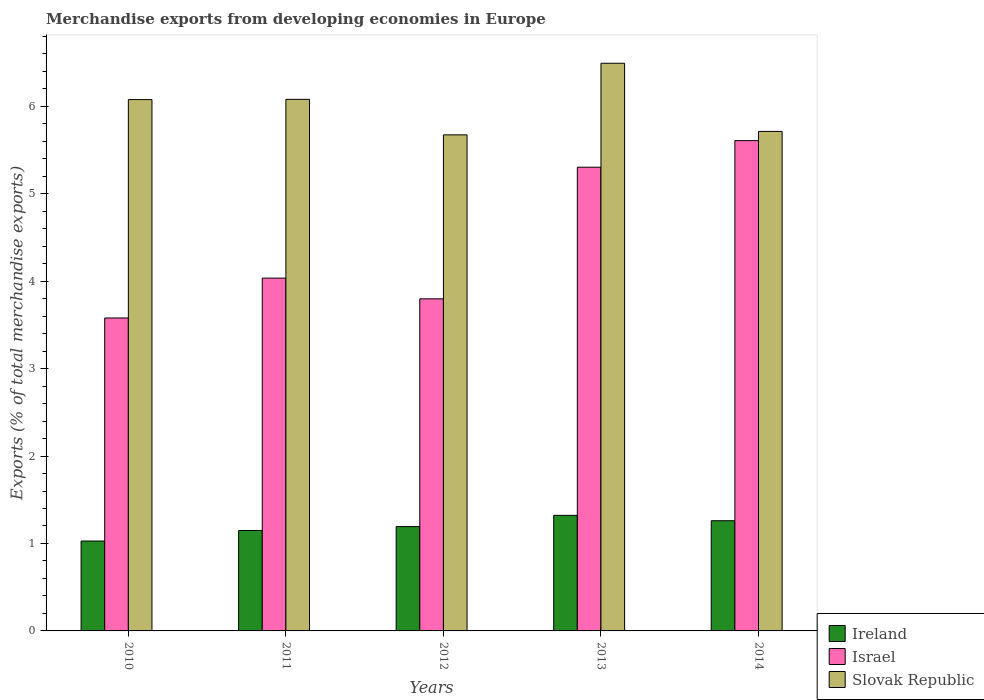How many different coloured bars are there?
Keep it short and to the point. 3. Are the number of bars per tick equal to the number of legend labels?
Provide a short and direct response. Yes. How many bars are there on the 2nd tick from the right?
Ensure brevity in your answer.  3. In how many cases, is the number of bars for a given year not equal to the number of legend labels?
Your answer should be very brief. 0. What is the percentage of total merchandise exports in Ireland in 2014?
Your answer should be compact. 1.26. Across all years, what is the maximum percentage of total merchandise exports in Ireland?
Keep it short and to the point. 1.32. Across all years, what is the minimum percentage of total merchandise exports in Israel?
Make the answer very short. 3.58. In which year was the percentage of total merchandise exports in Ireland minimum?
Your answer should be very brief. 2010. What is the total percentage of total merchandise exports in Slovak Republic in the graph?
Ensure brevity in your answer.  30.03. What is the difference between the percentage of total merchandise exports in Ireland in 2010 and that in 2013?
Offer a terse response. -0.29. What is the difference between the percentage of total merchandise exports in Israel in 2014 and the percentage of total merchandise exports in Slovak Republic in 2013?
Your answer should be very brief. -0.88. What is the average percentage of total merchandise exports in Ireland per year?
Your answer should be compact. 1.19. In the year 2014, what is the difference between the percentage of total merchandise exports in Israel and percentage of total merchandise exports in Ireland?
Provide a succinct answer. 4.35. In how many years, is the percentage of total merchandise exports in Slovak Republic greater than 4.2 %?
Make the answer very short. 5. What is the ratio of the percentage of total merchandise exports in Ireland in 2013 to that in 2014?
Provide a succinct answer. 1.05. Is the percentage of total merchandise exports in Israel in 2011 less than that in 2014?
Your answer should be very brief. Yes. Is the difference between the percentage of total merchandise exports in Israel in 2012 and 2014 greater than the difference between the percentage of total merchandise exports in Ireland in 2012 and 2014?
Your answer should be compact. No. What is the difference between the highest and the second highest percentage of total merchandise exports in Slovak Republic?
Offer a very short reply. 0.41. What is the difference between the highest and the lowest percentage of total merchandise exports in Slovak Republic?
Make the answer very short. 0.82. In how many years, is the percentage of total merchandise exports in Ireland greater than the average percentage of total merchandise exports in Ireland taken over all years?
Your response must be concise. 3. Is the sum of the percentage of total merchandise exports in Israel in 2011 and 2013 greater than the maximum percentage of total merchandise exports in Ireland across all years?
Keep it short and to the point. Yes. What does the 3rd bar from the left in 2014 represents?
Offer a terse response. Slovak Republic. What does the 1st bar from the right in 2013 represents?
Make the answer very short. Slovak Republic. Is it the case that in every year, the sum of the percentage of total merchandise exports in Slovak Republic and percentage of total merchandise exports in Israel is greater than the percentage of total merchandise exports in Ireland?
Give a very brief answer. Yes. Are all the bars in the graph horizontal?
Offer a terse response. No. What is the difference between two consecutive major ticks on the Y-axis?
Provide a succinct answer. 1. Does the graph contain grids?
Your answer should be compact. No. How are the legend labels stacked?
Your response must be concise. Vertical. What is the title of the graph?
Provide a succinct answer. Merchandise exports from developing economies in Europe. Does "Sudan" appear as one of the legend labels in the graph?
Provide a short and direct response. No. What is the label or title of the Y-axis?
Offer a very short reply. Exports (% of total merchandise exports). What is the Exports (% of total merchandise exports) in Ireland in 2010?
Ensure brevity in your answer.  1.03. What is the Exports (% of total merchandise exports) in Israel in 2010?
Offer a terse response. 3.58. What is the Exports (% of total merchandise exports) in Slovak Republic in 2010?
Offer a terse response. 6.08. What is the Exports (% of total merchandise exports) in Ireland in 2011?
Give a very brief answer. 1.15. What is the Exports (% of total merchandise exports) in Israel in 2011?
Keep it short and to the point. 4.03. What is the Exports (% of total merchandise exports) of Slovak Republic in 2011?
Your answer should be very brief. 6.08. What is the Exports (% of total merchandise exports) of Ireland in 2012?
Make the answer very short. 1.19. What is the Exports (% of total merchandise exports) of Israel in 2012?
Give a very brief answer. 3.8. What is the Exports (% of total merchandise exports) of Slovak Republic in 2012?
Make the answer very short. 5.67. What is the Exports (% of total merchandise exports) of Ireland in 2013?
Provide a short and direct response. 1.32. What is the Exports (% of total merchandise exports) in Israel in 2013?
Give a very brief answer. 5.3. What is the Exports (% of total merchandise exports) in Slovak Republic in 2013?
Provide a short and direct response. 6.49. What is the Exports (% of total merchandise exports) in Ireland in 2014?
Your response must be concise. 1.26. What is the Exports (% of total merchandise exports) in Israel in 2014?
Give a very brief answer. 5.61. What is the Exports (% of total merchandise exports) of Slovak Republic in 2014?
Offer a very short reply. 5.71. Across all years, what is the maximum Exports (% of total merchandise exports) in Ireland?
Give a very brief answer. 1.32. Across all years, what is the maximum Exports (% of total merchandise exports) in Israel?
Ensure brevity in your answer.  5.61. Across all years, what is the maximum Exports (% of total merchandise exports) in Slovak Republic?
Offer a very short reply. 6.49. Across all years, what is the minimum Exports (% of total merchandise exports) in Ireland?
Provide a short and direct response. 1.03. Across all years, what is the minimum Exports (% of total merchandise exports) of Israel?
Give a very brief answer. 3.58. Across all years, what is the minimum Exports (% of total merchandise exports) in Slovak Republic?
Give a very brief answer. 5.67. What is the total Exports (% of total merchandise exports) in Ireland in the graph?
Your response must be concise. 5.95. What is the total Exports (% of total merchandise exports) in Israel in the graph?
Your answer should be compact. 22.32. What is the total Exports (% of total merchandise exports) in Slovak Republic in the graph?
Ensure brevity in your answer.  30.03. What is the difference between the Exports (% of total merchandise exports) in Ireland in 2010 and that in 2011?
Make the answer very short. -0.12. What is the difference between the Exports (% of total merchandise exports) of Israel in 2010 and that in 2011?
Keep it short and to the point. -0.46. What is the difference between the Exports (% of total merchandise exports) in Slovak Republic in 2010 and that in 2011?
Provide a short and direct response. -0. What is the difference between the Exports (% of total merchandise exports) in Ireland in 2010 and that in 2012?
Provide a short and direct response. -0.17. What is the difference between the Exports (% of total merchandise exports) in Israel in 2010 and that in 2012?
Ensure brevity in your answer.  -0.22. What is the difference between the Exports (% of total merchandise exports) of Slovak Republic in 2010 and that in 2012?
Give a very brief answer. 0.4. What is the difference between the Exports (% of total merchandise exports) in Ireland in 2010 and that in 2013?
Give a very brief answer. -0.29. What is the difference between the Exports (% of total merchandise exports) in Israel in 2010 and that in 2013?
Your response must be concise. -1.72. What is the difference between the Exports (% of total merchandise exports) in Slovak Republic in 2010 and that in 2013?
Your response must be concise. -0.42. What is the difference between the Exports (% of total merchandise exports) of Ireland in 2010 and that in 2014?
Offer a terse response. -0.23. What is the difference between the Exports (% of total merchandise exports) in Israel in 2010 and that in 2014?
Make the answer very short. -2.03. What is the difference between the Exports (% of total merchandise exports) in Slovak Republic in 2010 and that in 2014?
Your answer should be very brief. 0.36. What is the difference between the Exports (% of total merchandise exports) of Ireland in 2011 and that in 2012?
Provide a succinct answer. -0.05. What is the difference between the Exports (% of total merchandise exports) in Israel in 2011 and that in 2012?
Your response must be concise. 0.24. What is the difference between the Exports (% of total merchandise exports) in Slovak Republic in 2011 and that in 2012?
Make the answer very short. 0.41. What is the difference between the Exports (% of total merchandise exports) in Ireland in 2011 and that in 2013?
Ensure brevity in your answer.  -0.17. What is the difference between the Exports (% of total merchandise exports) of Israel in 2011 and that in 2013?
Your answer should be compact. -1.27. What is the difference between the Exports (% of total merchandise exports) in Slovak Republic in 2011 and that in 2013?
Offer a terse response. -0.41. What is the difference between the Exports (% of total merchandise exports) of Ireland in 2011 and that in 2014?
Your answer should be compact. -0.11. What is the difference between the Exports (% of total merchandise exports) in Israel in 2011 and that in 2014?
Your answer should be compact. -1.57. What is the difference between the Exports (% of total merchandise exports) in Slovak Republic in 2011 and that in 2014?
Provide a succinct answer. 0.37. What is the difference between the Exports (% of total merchandise exports) of Ireland in 2012 and that in 2013?
Give a very brief answer. -0.13. What is the difference between the Exports (% of total merchandise exports) in Israel in 2012 and that in 2013?
Ensure brevity in your answer.  -1.51. What is the difference between the Exports (% of total merchandise exports) of Slovak Republic in 2012 and that in 2013?
Make the answer very short. -0.82. What is the difference between the Exports (% of total merchandise exports) of Ireland in 2012 and that in 2014?
Give a very brief answer. -0.07. What is the difference between the Exports (% of total merchandise exports) in Israel in 2012 and that in 2014?
Ensure brevity in your answer.  -1.81. What is the difference between the Exports (% of total merchandise exports) of Slovak Republic in 2012 and that in 2014?
Your answer should be compact. -0.04. What is the difference between the Exports (% of total merchandise exports) of Ireland in 2013 and that in 2014?
Your response must be concise. 0.06. What is the difference between the Exports (% of total merchandise exports) of Israel in 2013 and that in 2014?
Give a very brief answer. -0.3. What is the difference between the Exports (% of total merchandise exports) in Slovak Republic in 2013 and that in 2014?
Keep it short and to the point. 0.78. What is the difference between the Exports (% of total merchandise exports) of Ireland in 2010 and the Exports (% of total merchandise exports) of Israel in 2011?
Provide a succinct answer. -3.01. What is the difference between the Exports (% of total merchandise exports) of Ireland in 2010 and the Exports (% of total merchandise exports) of Slovak Republic in 2011?
Make the answer very short. -5.05. What is the difference between the Exports (% of total merchandise exports) of Israel in 2010 and the Exports (% of total merchandise exports) of Slovak Republic in 2011?
Ensure brevity in your answer.  -2.5. What is the difference between the Exports (% of total merchandise exports) in Ireland in 2010 and the Exports (% of total merchandise exports) in Israel in 2012?
Make the answer very short. -2.77. What is the difference between the Exports (% of total merchandise exports) in Ireland in 2010 and the Exports (% of total merchandise exports) in Slovak Republic in 2012?
Provide a short and direct response. -4.65. What is the difference between the Exports (% of total merchandise exports) in Israel in 2010 and the Exports (% of total merchandise exports) in Slovak Republic in 2012?
Offer a very short reply. -2.09. What is the difference between the Exports (% of total merchandise exports) in Ireland in 2010 and the Exports (% of total merchandise exports) in Israel in 2013?
Give a very brief answer. -4.28. What is the difference between the Exports (% of total merchandise exports) in Ireland in 2010 and the Exports (% of total merchandise exports) in Slovak Republic in 2013?
Keep it short and to the point. -5.46. What is the difference between the Exports (% of total merchandise exports) of Israel in 2010 and the Exports (% of total merchandise exports) of Slovak Republic in 2013?
Offer a very short reply. -2.91. What is the difference between the Exports (% of total merchandise exports) of Ireland in 2010 and the Exports (% of total merchandise exports) of Israel in 2014?
Provide a succinct answer. -4.58. What is the difference between the Exports (% of total merchandise exports) of Ireland in 2010 and the Exports (% of total merchandise exports) of Slovak Republic in 2014?
Ensure brevity in your answer.  -4.68. What is the difference between the Exports (% of total merchandise exports) in Israel in 2010 and the Exports (% of total merchandise exports) in Slovak Republic in 2014?
Offer a very short reply. -2.13. What is the difference between the Exports (% of total merchandise exports) in Ireland in 2011 and the Exports (% of total merchandise exports) in Israel in 2012?
Ensure brevity in your answer.  -2.65. What is the difference between the Exports (% of total merchandise exports) of Ireland in 2011 and the Exports (% of total merchandise exports) of Slovak Republic in 2012?
Provide a succinct answer. -4.53. What is the difference between the Exports (% of total merchandise exports) in Israel in 2011 and the Exports (% of total merchandise exports) in Slovak Republic in 2012?
Offer a terse response. -1.64. What is the difference between the Exports (% of total merchandise exports) in Ireland in 2011 and the Exports (% of total merchandise exports) in Israel in 2013?
Keep it short and to the point. -4.16. What is the difference between the Exports (% of total merchandise exports) in Ireland in 2011 and the Exports (% of total merchandise exports) in Slovak Republic in 2013?
Your answer should be very brief. -5.34. What is the difference between the Exports (% of total merchandise exports) in Israel in 2011 and the Exports (% of total merchandise exports) in Slovak Republic in 2013?
Provide a short and direct response. -2.46. What is the difference between the Exports (% of total merchandise exports) in Ireland in 2011 and the Exports (% of total merchandise exports) in Israel in 2014?
Keep it short and to the point. -4.46. What is the difference between the Exports (% of total merchandise exports) of Ireland in 2011 and the Exports (% of total merchandise exports) of Slovak Republic in 2014?
Make the answer very short. -4.56. What is the difference between the Exports (% of total merchandise exports) in Israel in 2011 and the Exports (% of total merchandise exports) in Slovak Republic in 2014?
Offer a terse response. -1.68. What is the difference between the Exports (% of total merchandise exports) of Ireland in 2012 and the Exports (% of total merchandise exports) of Israel in 2013?
Give a very brief answer. -4.11. What is the difference between the Exports (% of total merchandise exports) in Ireland in 2012 and the Exports (% of total merchandise exports) in Slovak Republic in 2013?
Give a very brief answer. -5.3. What is the difference between the Exports (% of total merchandise exports) in Israel in 2012 and the Exports (% of total merchandise exports) in Slovak Republic in 2013?
Your response must be concise. -2.69. What is the difference between the Exports (% of total merchandise exports) of Ireland in 2012 and the Exports (% of total merchandise exports) of Israel in 2014?
Your answer should be compact. -4.41. What is the difference between the Exports (% of total merchandise exports) of Ireland in 2012 and the Exports (% of total merchandise exports) of Slovak Republic in 2014?
Your answer should be very brief. -4.52. What is the difference between the Exports (% of total merchandise exports) in Israel in 2012 and the Exports (% of total merchandise exports) in Slovak Republic in 2014?
Ensure brevity in your answer.  -1.91. What is the difference between the Exports (% of total merchandise exports) of Ireland in 2013 and the Exports (% of total merchandise exports) of Israel in 2014?
Keep it short and to the point. -4.29. What is the difference between the Exports (% of total merchandise exports) of Ireland in 2013 and the Exports (% of total merchandise exports) of Slovak Republic in 2014?
Your answer should be compact. -4.39. What is the difference between the Exports (% of total merchandise exports) in Israel in 2013 and the Exports (% of total merchandise exports) in Slovak Republic in 2014?
Ensure brevity in your answer.  -0.41. What is the average Exports (% of total merchandise exports) in Ireland per year?
Offer a very short reply. 1.19. What is the average Exports (% of total merchandise exports) of Israel per year?
Make the answer very short. 4.46. What is the average Exports (% of total merchandise exports) of Slovak Republic per year?
Offer a very short reply. 6.01. In the year 2010, what is the difference between the Exports (% of total merchandise exports) in Ireland and Exports (% of total merchandise exports) in Israel?
Provide a short and direct response. -2.55. In the year 2010, what is the difference between the Exports (% of total merchandise exports) of Ireland and Exports (% of total merchandise exports) of Slovak Republic?
Provide a succinct answer. -5.05. In the year 2010, what is the difference between the Exports (% of total merchandise exports) of Israel and Exports (% of total merchandise exports) of Slovak Republic?
Keep it short and to the point. -2.5. In the year 2011, what is the difference between the Exports (% of total merchandise exports) of Ireland and Exports (% of total merchandise exports) of Israel?
Make the answer very short. -2.89. In the year 2011, what is the difference between the Exports (% of total merchandise exports) in Ireland and Exports (% of total merchandise exports) in Slovak Republic?
Your response must be concise. -4.93. In the year 2011, what is the difference between the Exports (% of total merchandise exports) in Israel and Exports (% of total merchandise exports) in Slovak Republic?
Offer a terse response. -2.04. In the year 2012, what is the difference between the Exports (% of total merchandise exports) of Ireland and Exports (% of total merchandise exports) of Israel?
Offer a very short reply. -2.6. In the year 2012, what is the difference between the Exports (% of total merchandise exports) of Ireland and Exports (% of total merchandise exports) of Slovak Republic?
Your answer should be very brief. -4.48. In the year 2012, what is the difference between the Exports (% of total merchandise exports) in Israel and Exports (% of total merchandise exports) in Slovak Republic?
Your answer should be compact. -1.88. In the year 2013, what is the difference between the Exports (% of total merchandise exports) of Ireland and Exports (% of total merchandise exports) of Israel?
Ensure brevity in your answer.  -3.98. In the year 2013, what is the difference between the Exports (% of total merchandise exports) of Ireland and Exports (% of total merchandise exports) of Slovak Republic?
Keep it short and to the point. -5.17. In the year 2013, what is the difference between the Exports (% of total merchandise exports) of Israel and Exports (% of total merchandise exports) of Slovak Republic?
Offer a terse response. -1.19. In the year 2014, what is the difference between the Exports (% of total merchandise exports) of Ireland and Exports (% of total merchandise exports) of Israel?
Offer a terse response. -4.35. In the year 2014, what is the difference between the Exports (% of total merchandise exports) of Ireland and Exports (% of total merchandise exports) of Slovak Republic?
Your answer should be very brief. -4.45. In the year 2014, what is the difference between the Exports (% of total merchandise exports) in Israel and Exports (% of total merchandise exports) in Slovak Republic?
Provide a short and direct response. -0.11. What is the ratio of the Exports (% of total merchandise exports) in Ireland in 2010 to that in 2011?
Offer a terse response. 0.9. What is the ratio of the Exports (% of total merchandise exports) in Israel in 2010 to that in 2011?
Make the answer very short. 0.89. What is the ratio of the Exports (% of total merchandise exports) in Slovak Republic in 2010 to that in 2011?
Your answer should be compact. 1. What is the ratio of the Exports (% of total merchandise exports) of Ireland in 2010 to that in 2012?
Provide a succinct answer. 0.86. What is the ratio of the Exports (% of total merchandise exports) in Israel in 2010 to that in 2012?
Your answer should be very brief. 0.94. What is the ratio of the Exports (% of total merchandise exports) in Slovak Republic in 2010 to that in 2012?
Offer a very short reply. 1.07. What is the ratio of the Exports (% of total merchandise exports) of Ireland in 2010 to that in 2013?
Offer a very short reply. 0.78. What is the ratio of the Exports (% of total merchandise exports) of Israel in 2010 to that in 2013?
Offer a terse response. 0.67. What is the ratio of the Exports (% of total merchandise exports) of Slovak Republic in 2010 to that in 2013?
Make the answer very short. 0.94. What is the ratio of the Exports (% of total merchandise exports) in Ireland in 2010 to that in 2014?
Provide a short and direct response. 0.82. What is the ratio of the Exports (% of total merchandise exports) in Israel in 2010 to that in 2014?
Offer a very short reply. 0.64. What is the ratio of the Exports (% of total merchandise exports) of Slovak Republic in 2010 to that in 2014?
Your answer should be compact. 1.06. What is the ratio of the Exports (% of total merchandise exports) in Ireland in 2011 to that in 2012?
Give a very brief answer. 0.96. What is the ratio of the Exports (% of total merchandise exports) of Israel in 2011 to that in 2012?
Offer a terse response. 1.06. What is the ratio of the Exports (% of total merchandise exports) of Slovak Republic in 2011 to that in 2012?
Offer a terse response. 1.07. What is the ratio of the Exports (% of total merchandise exports) in Ireland in 2011 to that in 2013?
Offer a terse response. 0.87. What is the ratio of the Exports (% of total merchandise exports) of Israel in 2011 to that in 2013?
Your answer should be very brief. 0.76. What is the ratio of the Exports (% of total merchandise exports) in Slovak Republic in 2011 to that in 2013?
Your answer should be compact. 0.94. What is the ratio of the Exports (% of total merchandise exports) of Ireland in 2011 to that in 2014?
Offer a very short reply. 0.91. What is the ratio of the Exports (% of total merchandise exports) in Israel in 2011 to that in 2014?
Keep it short and to the point. 0.72. What is the ratio of the Exports (% of total merchandise exports) of Slovak Republic in 2011 to that in 2014?
Your answer should be compact. 1.06. What is the ratio of the Exports (% of total merchandise exports) in Ireland in 2012 to that in 2013?
Give a very brief answer. 0.9. What is the ratio of the Exports (% of total merchandise exports) in Israel in 2012 to that in 2013?
Offer a terse response. 0.72. What is the ratio of the Exports (% of total merchandise exports) of Slovak Republic in 2012 to that in 2013?
Provide a succinct answer. 0.87. What is the ratio of the Exports (% of total merchandise exports) of Ireland in 2012 to that in 2014?
Your response must be concise. 0.95. What is the ratio of the Exports (% of total merchandise exports) of Israel in 2012 to that in 2014?
Your answer should be compact. 0.68. What is the ratio of the Exports (% of total merchandise exports) in Slovak Republic in 2012 to that in 2014?
Your answer should be very brief. 0.99. What is the ratio of the Exports (% of total merchandise exports) of Ireland in 2013 to that in 2014?
Your answer should be compact. 1.05. What is the ratio of the Exports (% of total merchandise exports) in Israel in 2013 to that in 2014?
Your answer should be very brief. 0.95. What is the ratio of the Exports (% of total merchandise exports) in Slovak Republic in 2013 to that in 2014?
Your answer should be compact. 1.14. What is the difference between the highest and the second highest Exports (% of total merchandise exports) of Ireland?
Offer a terse response. 0.06. What is the difference between the highest and the second highest Exports (% of total merchandise exports) in Israel?
Your answer should be compact. 0.3. What is the difference between the highest and the second highest Exports (% of total merchandise exports) in Slovak Republic?
Make the answer very short. 0.41. What is the difference between the highest and the lowest Exports (% of total merchandise exports) of Ireland?
Keep it short and to the point. 0.29. What is the difference between the highest and the lowest Exports (% of total merchandise exports) in Israel?
Give a very brief answer. 2.03. What is the difference between the highest and the lowest Exports (% of total merchandise exports) in Slovak Republic?
Make the answer very short. 0.82. 